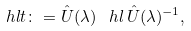<formula> <loc_0><loc_0><loc_500><loc_500>\ h l t \colon = \hat { U } ( \lambda ) \, \ h l \, \hat { U } ( \lambda ) ^ { - 1 } ,</formula> 